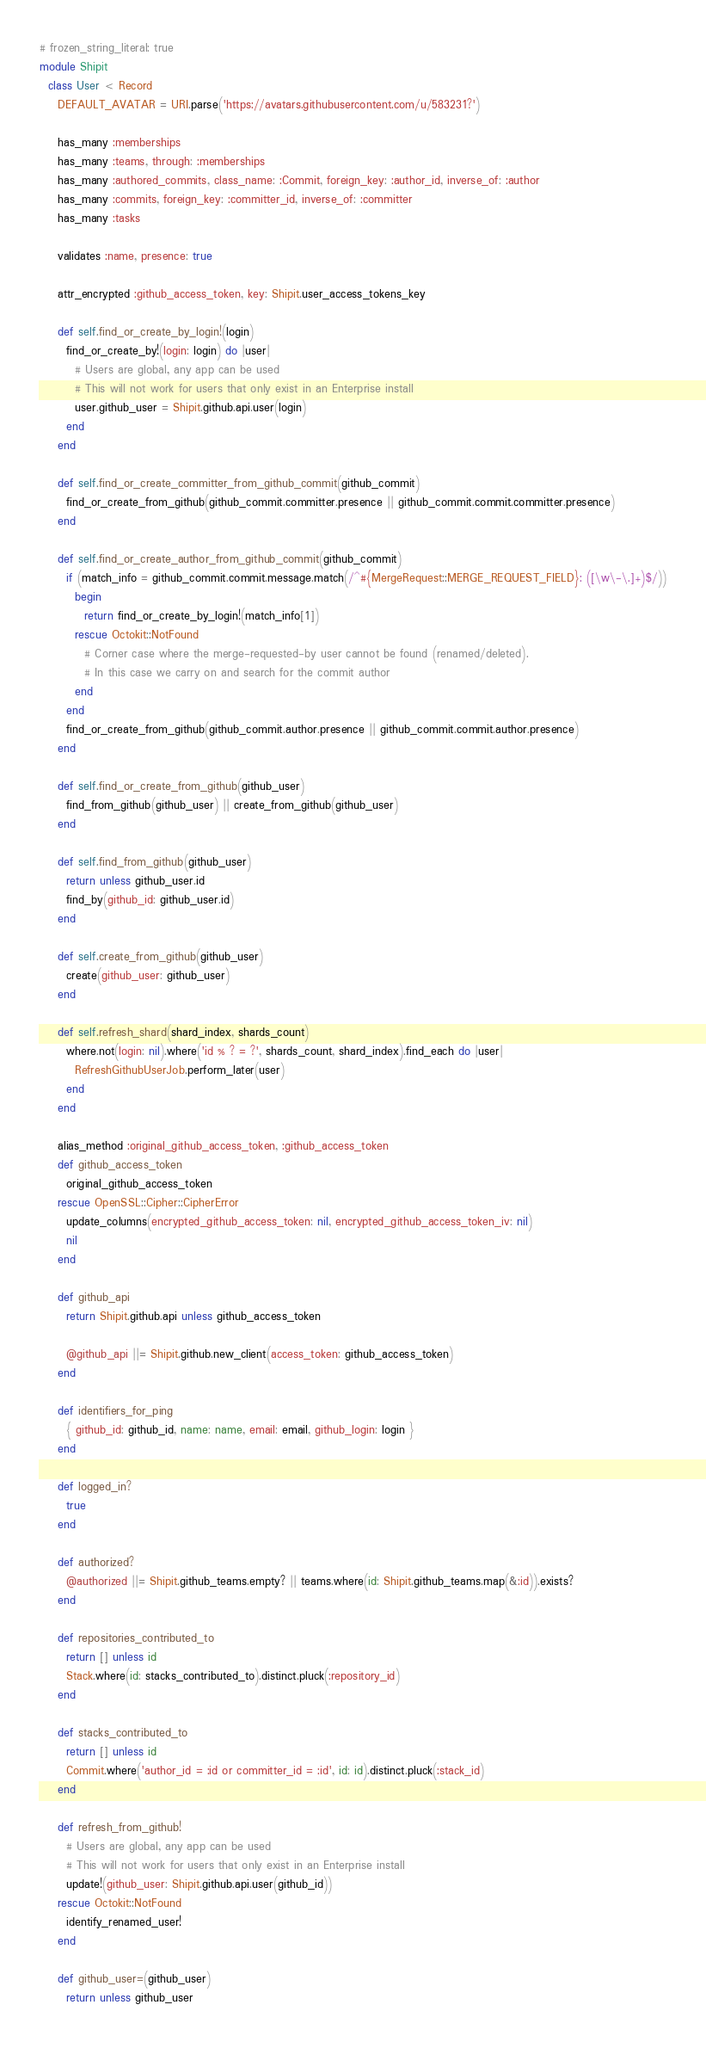<code> <loc_0><loc_0><loc_500><loc_500><_Ruby_># frozen_string_literal: true
module Shipit
  class User < Record
    DEFAULT_AVATAR = URI.parse('https://avatars.githubusercontent.com/u/583231?')

    has_many :memberships
    has_many :teams, through: :memberships
    has_many :authored_commits, class_name: :Commit, foreign_key: :author_id, inverse_of: :author
    has_many :commits, foreign_key: :committer_id, inverse_of: :committer
    has_many :tasks

    validates :name, presence: true

    attr_encrypted :github_access_token, key: Shipit.user_access_tokens_key

    def self.find_or_create_by_login!(login)
      find_or_create_by!(login: login) do |user|
        # Users are global, any app can be used
        # This will not work for users that only exist in an Enterprise install
        user.github_user = Shipit.github.api.user(login)
      end
    end

    def self.find_or_create_committer_from_github_commit(github_commit)
      find_or_create_from_github(github_commit.committer.presence || github_commit.commit.committer.presence)
    end

    def self.find_or_create_author_from_github_commit(github_commit)
      if (match_info = github_commit.commit.message.match(/^#{MergeRequest::MERGE_REQUEST_FIELD}: ([\w\-\.]+)$/))
        begin
          return find_or_create_by_login!(match_info[1])
        rescue Octokit::NotFound
          # Corner case where the merge-requested-by user cannot be found (renamed/deleted).
          # In this case we carry on and search for the commit author
        end
      end
      find_or_create_from_github(github_commit.author.presence || github_commit.commit.author.presence)
    end

    def self.find_or_create_from_github(github_user)
      find_from_github(github_user) || create_from_github(github_user)
    end

    def self.find_from_github(github_user)
      return unless github_user.id
      find_by(github_id: github_user.id)
    end

    def self.create_from_github(github_user)
      create(github_user: github_user)
    end

    def self.refresh_shard(shard_index, shards_count)
      where.not(login: nil).where('id % ? = ?', shards_count, shard_index).find_each do |user|
        RefreshGithubUserJob.perform_later(user)
      end
    end

    alias_method :original_github_access_token, :github_access_token
    def github_access_token
      original_github_access_token
    rescue OpenSSL::Cipher::CipherError
      update_columns(encrypted_github_access_token: nil, encrypted_github_access_token_iv: nil)
      nil
    end

    def github_api
      return Shipit.github.api unless github_access_token

      @github_api ||= Shipit.github.new_client(access_token: github_access_token)
    end

    def identifiers_for_ping
      { github_id: github_id, name: name, email: email, github_login: login }
    end

    def logged_in?
      true
    end

    def authorized?
      @authorized ||= Shipit.github_teams.empty? || teams.where(id: Shipit.github_teams.map(&:id)).exists?
    end

    def repositories_contributed_to
      return [] unless id
      Stack.where(id: stacks_contributed_to).distinct.pluck(:repository_id)
    end

    def stacks_contributed_to
      return [] unless id
      Commit.where('author_id = :id or committer_id = :id', id: id).distinct.pluck(:stack_id)
    end

    def refresh_from_github!
      # Users are global, any app can be used
      # This will not work for users that only exist in an Enterprise install
      update!(github_user: Shipit.github.api.user(github_id))
    rescue Octokit::NotFound
      identify_renamed_user!
    end

    def github_user=(github_user)
      return unless github_user
</code> 